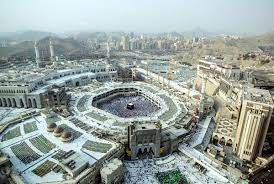Imagine a futuristic scenario where this holy site incorporates advanced technology. What changes might we see? In a futuristic scenario, the Great Mosque of Mecca might see the integration of advanced technologies aimed at enhancing the spiritual experience and managing the immense crowds. We could envision the use of augmented reality (AR) headsets for pilgrims, providing real-time translations and guidance during rituals. Intelligent robots might assist with crowd control, guiding visitors to less congested areas to ensure safety. The Kaaba might be surrounded by holographic displays projecting historical narrations and religious texts for educational purposes. The surrounding buildings could feature renewable energy sources, transforming Mecca into a sustainable city. Moreover, advanced surveillance and health monitoring systems might ensure the well-being of pilgrims, providing immediate medical assistance when needed. This blend of tradition and technology would create a seamless and enriched pilgrimage experience while maintaining the sacredness of the site. What might a busy weekday look like around this area? On a typical busy weekday, the area around the Great Mosque of Mecca is bustling with activity. Pilgrims from various parts of the world, dressed in white ihram clothing, move purposefully around the mosque, engaging in their prayers and rituals. Vendors in the adjacent marketplaces offer traditional Islamic attire, prayer mats, and souvenirs. The air is filled with a blend of different languages, reflecting the diverse nationalities of the visitors. Street cleaners and maintenance staff work diligently to keep the area pristine despite the constant flow of people. The nearby streets are alive with traffic, with buses and cars transporting pilgrims to and from their accommodations. There's a palpable sense of devotion and unity as people gather for communal prayers, creating an atmosphere of reverence and purpose. If this image were part of a storybook, what kind of tale could revolve around it? In a mythical tale inspired by this image, we could follow the journey of a young pilgrim named Tariq, who embarks on a spiritual quest to the Great Mosque of Mecca. As Tariq enters the magnificent mosque, he is entrusted with an ancient relic said to possess the power to unite humanity. This relic, known as the 'Heart of Unity,' can only be activated through pure devotion and acts of kindness. Throughout his journey, Tariq encounters various characters—a wise old scholar, a cheerful merchant, and a mysterious guide—each contributing to his understanding of faith, humility, and compassion. With the Kaaba as his focal point, Tariq's adventures take him through the bustling streets of Mecca and into the serene surrounding mountains, where he must overcome trials that test his faith and resolve. The story intertwines the sacred heritage of the mosque with mythical elements, exploring themes of unity, peace, and the transformative power of pilgrimage. 